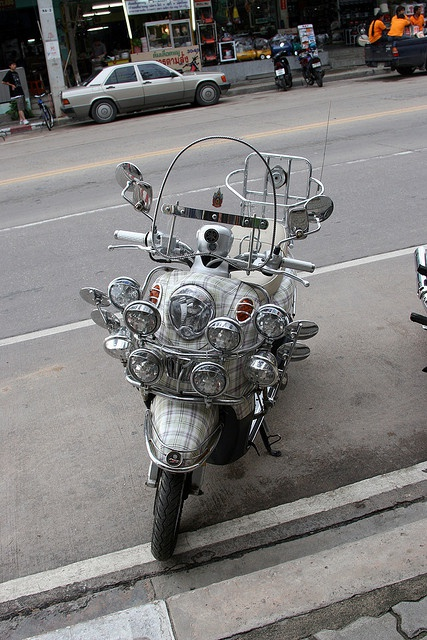Describe the objects in this image and their specific colors. I can see motorcycle in black, darkgray, gray, and lightgray tones, car in black, gray, lightgray, and darkgray tones, truck in black, gray, and maroon tones, people in black, gray, and maroon tones, and motorcycle in black, white, gray, and darkgray tones in this image. 